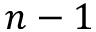Convert formula to latex. <formula><loc_0><loc_0><loc_500><loc_500>n - 1</formula> 